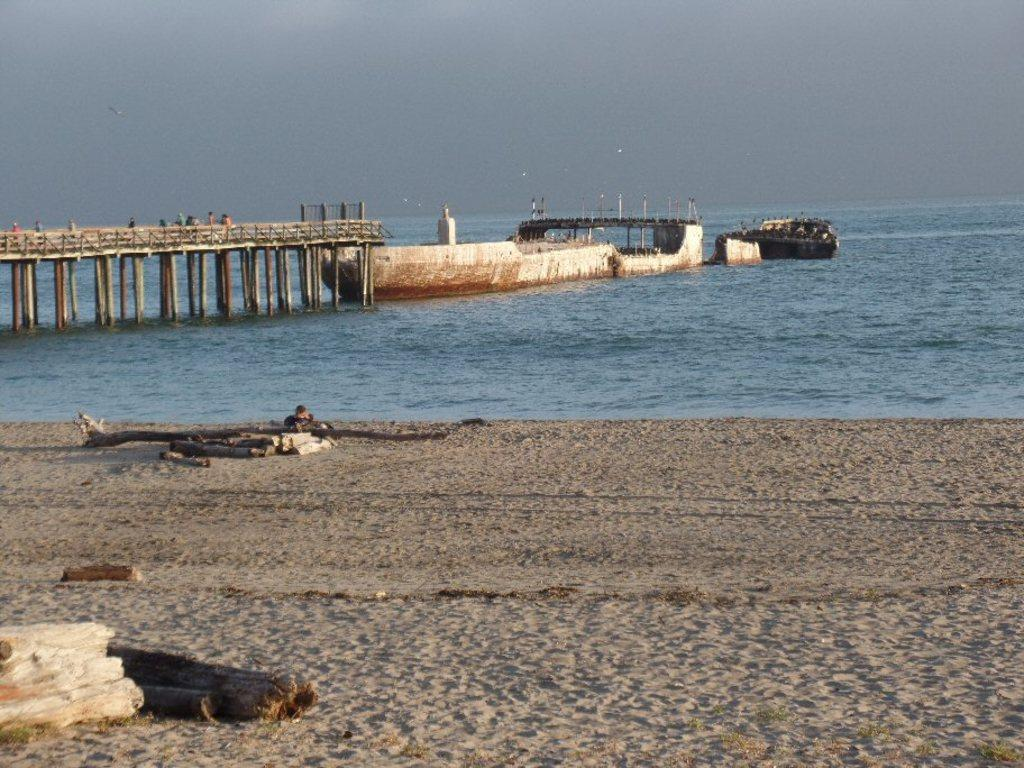What type of terrain is visible in the image? There is sand in the image. What objects are made of wood in the image? There are wooden logs in the image. What can be seen in the distance in the image? There is water, a bridge, pillars, people, railings, boats, and the sky visible in the background of the image. What type of shop can be seen in the image? There is no shop present in the image. What is the window used for in the image? There is no window present in the image. 